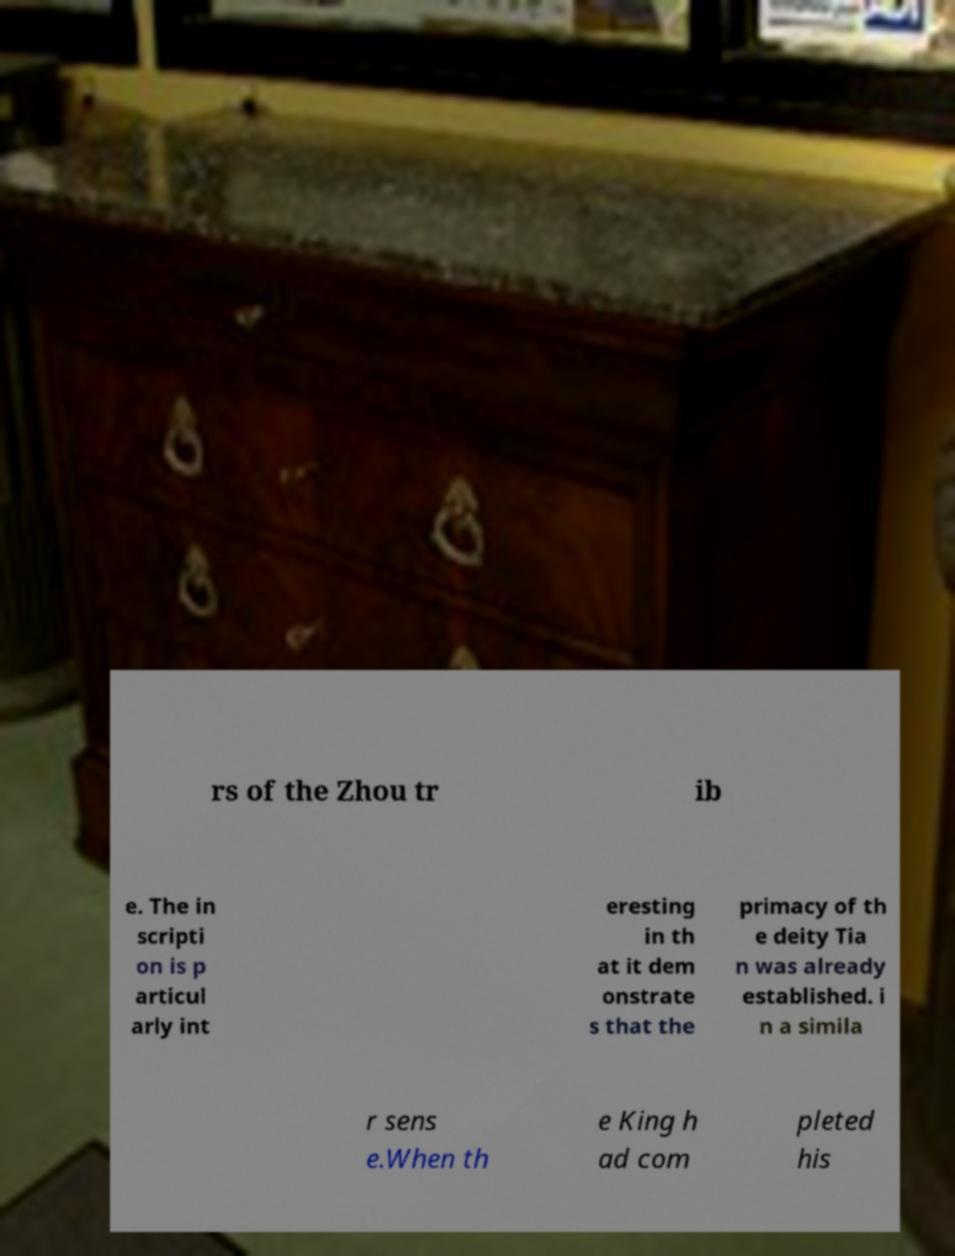Please read and relay the text visible in this image. What does it say? rs of the Zhou tr ib e. The in scripti on is p articul arly int eresting in th at it dem onstrate s that the primacy of th e deity Tia n was already established. i n a simila r sens e.When th e King h ad com pleted his 